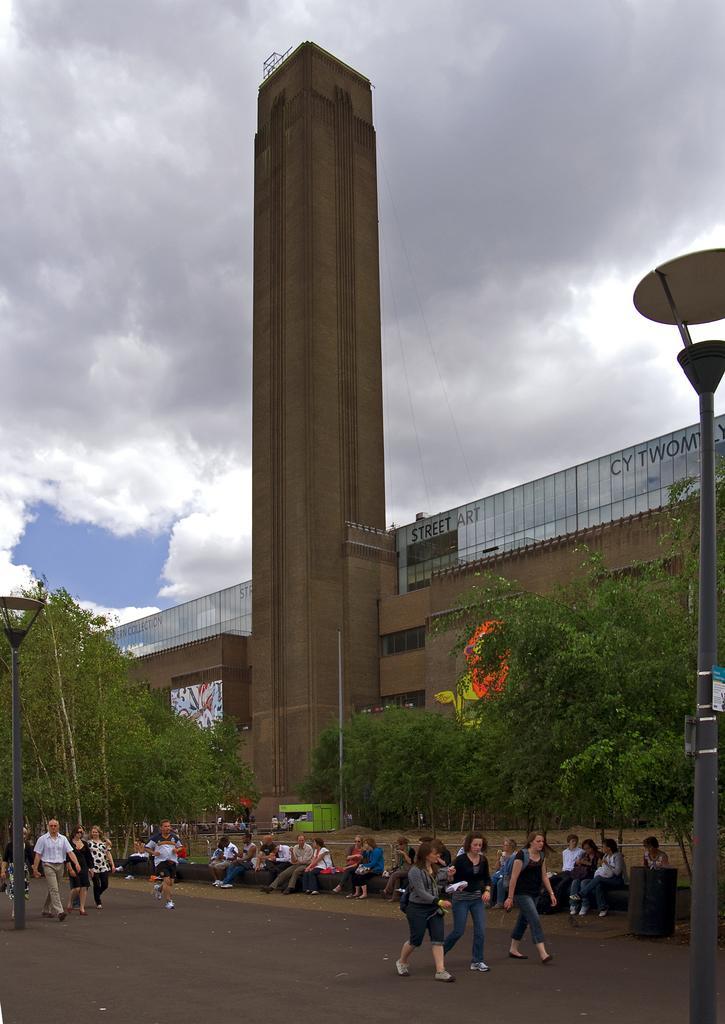Can you describe this image briefly? The picture is taken outside a city. In the foreground of the picture there are many people walking and few are sitting. In the center of the picture there are trees, poles and a building. Sky is cloudy. 